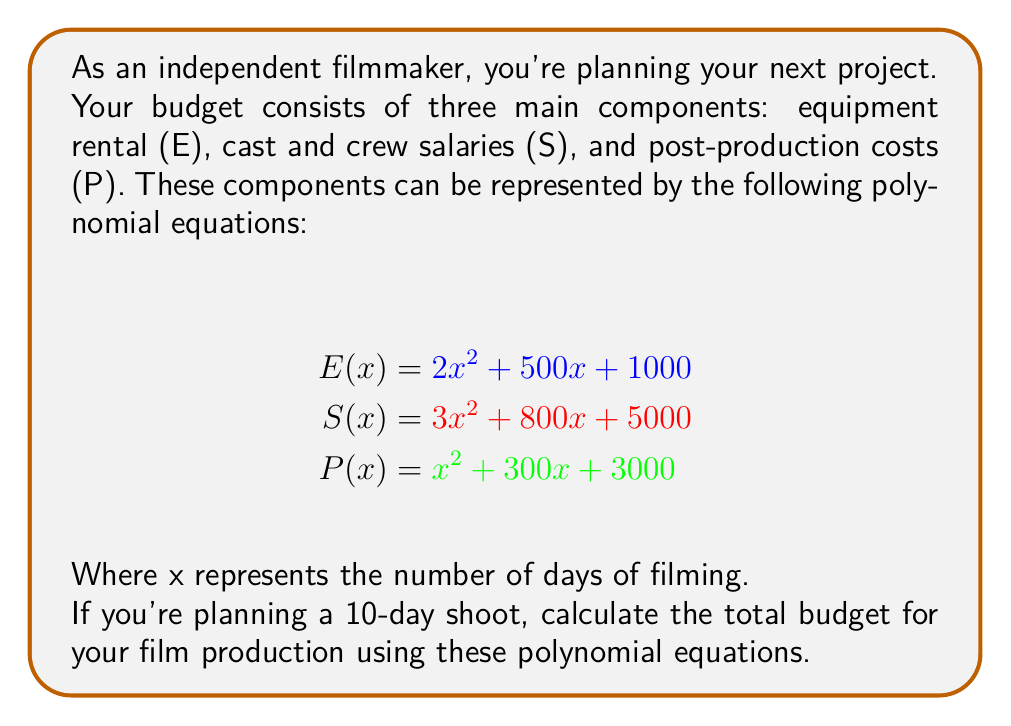Provide a solution to this math problem. To solve this problem, we need to follow these steps:

1. Substitute x = 10 into each equation:

   For E(x):
   $E(10) = 2(10)^2 + 500(10) + 1000$
   $= 2(100) + 5000 + 1000$
   $= 200 + 5000 + 1000$
   $= 6200$

   For S(x):
   $S(10) = 3(10)^2 + 800(10) + 5000$
   $= 3(100) + 8000 + 5000$
   $= 300 + 8000 + 5000$
   $= 13300$

   For P(x):
   $P(10) = (10)^2 + 300(10) + 3000$
   $= 100 + 3000 + 3000$
   $= 6100$

2. Sum up the results to get the total budget:

   Total Budget = E(10) + S(10) + P(10)
   $= 6200 + 13300 + 6100$
   $= 25600$

Therefore, the total budget for a 10-day film production is $25,600.
Answer: $25,600 